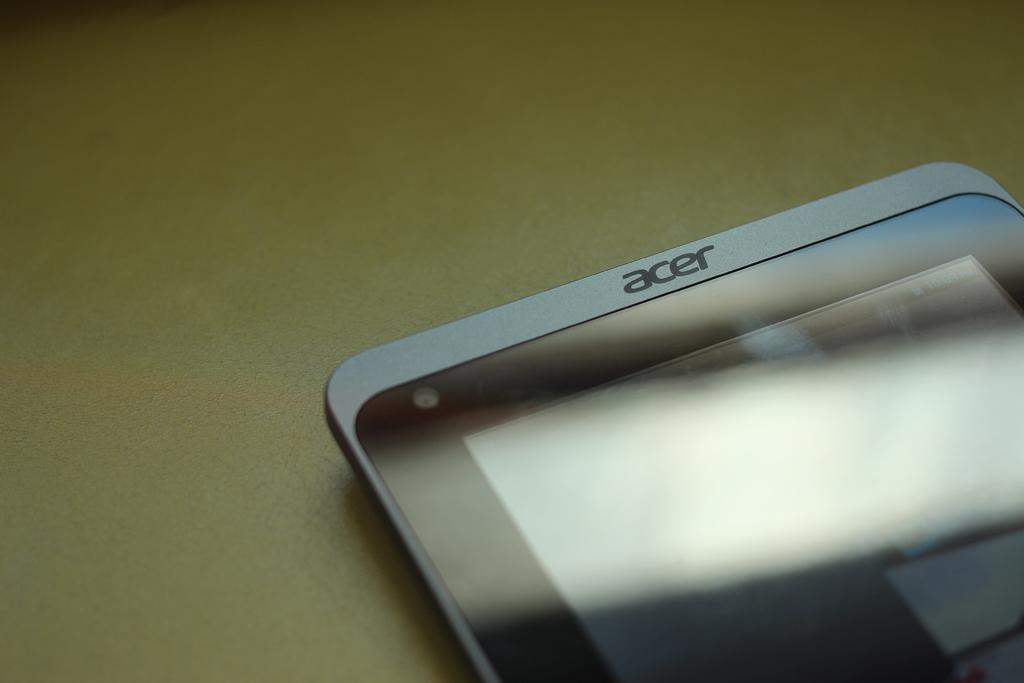What is the brand?
Your answer should be compact. Acer. 